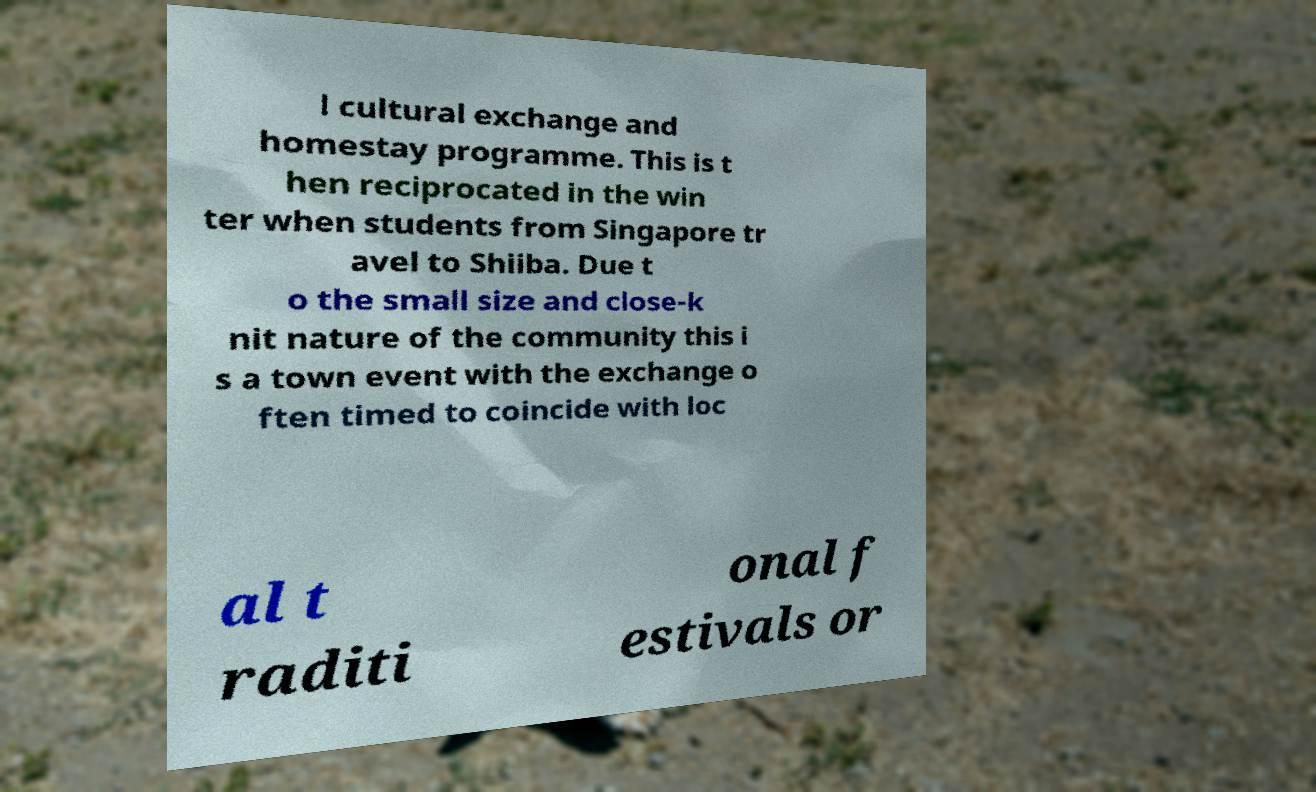There's text embedded in this image that I need extracted. Can you transcribe it verbatim? l cultural exchange and homestay programme. This is t hen reciprocated in the win ter when students from Singapore tr avel to Shiiba. Due t o the small size and close-k nit nature of the community this i s a town event with the exchange o ften timed to coincide with loc al t raditi onal f estivals or 